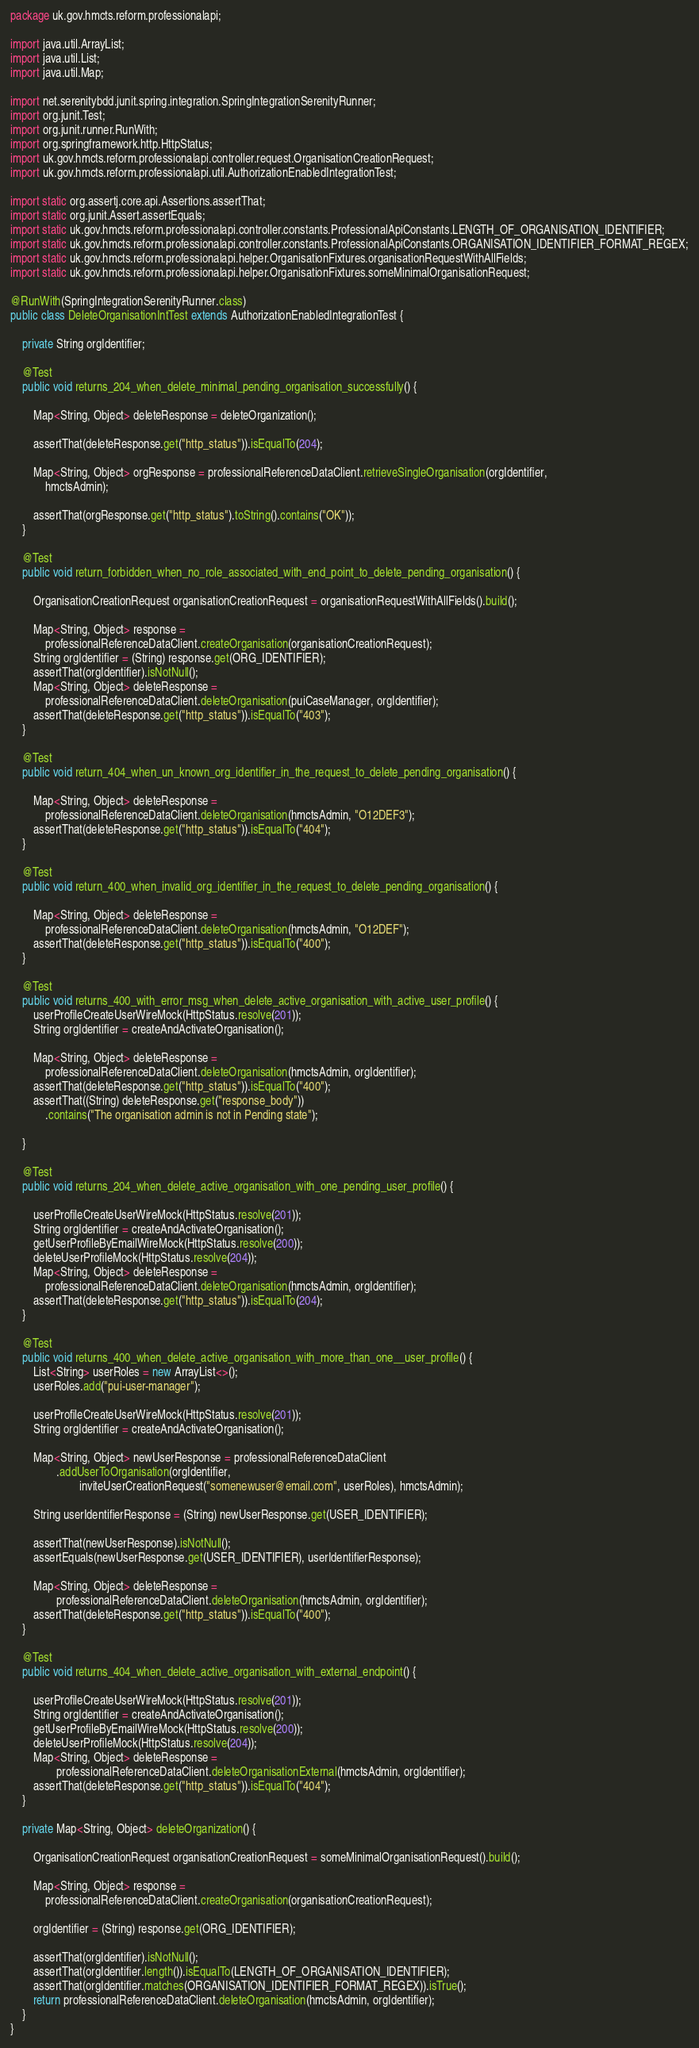Convert code to text. <code><loc_0><loc_0><loc_500><loc_500><_Java_>package uk.gov.hmcts.reform.professionalapi;

import java.util.ArrayList;
import java.util.List;
import java.util.Map;

import net.serenitybdd.junit.spring.integration.SpringIntegrationSerenityRunner;
import org.junit.Test;
import org.junit.runner.RunWith;
import org.springframework.http.HttpStatus;
import uk.gov.hmcts.reform.professionalapi.controller.request.OrganisationCreationRequest;
import uk.gov.hmcts.reform.professionalapi.util.AuthorizationEnabledIntegrationTest;

import static org.assertj.core.api.Assertions.assertThat;
import static org.junit.Assert.assertEquals;
import static uk.gov.hmcts.reform.professionalapi.controller.constants.ProfessionalApiConstants.LENGTH_OF_ORGANISATION_IDENTIFIER;
import static uk.gov.hmcts.reform.professionalapi.controller.constants.ProfessionalApiConstants.ORGANISATION_IDENTIFIER_FORMAT_REGEX;
import static uk.gov.hmcts.reform.professionalapi.helper.OrganisationFixtures.organisationRequestWithAllFields;
import static uk.gov.hmcts.reform.professionalapi.helper.OrganisationFixtures.someMinimalOrganisationRequest;

@RunWith(SpringIntegrationSerenityRunner.class)
public class DeleteOrganisationIntTest extends AuthorizationEnabledIntegrationTest {

    private String orgIdentifier;

    @Test
    public void returns_204_when_delete_minimal_pending_organisation_successfully() {

        Map<String, Object> deleteResponse = deleteOrganization();

        assertThat(deleteResponse.get("http_status")).isEqualTo(204);

        Map<String, Object> orgResponse = professionalReferenceDataClient.retrieveSingleOrganisation(orgIdentifier,
            hmctsAdmin);

        assertThat(orgResponse.get("http_status").toString().contains("OK"));
    }

    @Test
    public void return_forbidden_when_no_role_associated_with_end_point_to_delete_pending_organisation() {

        OrganisationCreationRequest organisationCreationRequest = organisationRequestWithAllFields().build();

        Map<String, Object> response =
            professionalReferenceDataClient.createOrganisation(organisationCreationRequest);
        String orgIdentifier = (String) response.get(ORG_IDENTIFIER);
        assertThat(orgIdentifier).isNotNull();
        Map<String, Object> deleteResponse =
            professionalReferenceDataClient.deleteOrganisation(puiCaseManager, orgIdentifier);
        assertThat(deleteResponse.get("http_status")).isEqualTo("403");
    }

    @Test
    public void return_404_when_un_known_org_identifier_in_the_request_to_delete_pending_organisation() {

        Map<String, Object> deleteResponse =
            professionalReferenceDataClient.deleteOrganisation(hmctsAdmin, "O12DEF3");
        assertThat(deleteResponse.get("http_status")).isEqualTo("404");
    }

    @Test
    public void return_400_when_invalid_org_identifier_in_the_request_to_delete_pending_organisation() {

        Map<String, Object> deleteResponse =
            professionalReferenceDataClient.deleteOrganisation(hmctsAdmin, "O12DEF");
        assertThat(deleteResponse.get("http_status")).isEqualTo("400");
    }

    @Test
    public void returns_400_with_error_msg_when_delete_active_organisation_with_active_user_profile() {
        userProfileCreateUserWireMock(HttpStatus.resolve(201));
        String orgIdentifier = createAndActivateOrganisation();

        Map<String, Object> deleteResponse =
            professionalReferenceDataClient.deleteOrganisation(hmctsAdmin, orgIdentifier);
        assertThat(deleteResponse.get("http_status")).isEqualTo("400");
        assertThat((String) deleteResponse.get("response_body"))
            .contains("The organisation admin is not in Pending state");

    }

    @Test
    public void returns_204_when_delete_active_organisation_with_one_pending_user_profile() {

        userProfileCreateUserWireMock(HttpStatus.resolve(201));
        String orgIdentifier = createAndActivateOrganisation();
        getUserProfileByEmailWireMock(HttpStatus.resolve(200));
        deleteUserProfileMock(HttpStatus.resolve(204));
        Map<String, Object> deleteResponse =
            professionalReferenceDataClient.deleteOrganisation(hmctsAdmin, orgIdentifier);
        assertThat(deleteResponse.get("http_status")).isEqualTo(204);
    }

    @Test
    public void returns_400_when_delete_active_organisation_with_more_than_one__user_profile() {
        List<String> userRoles = new ArrayList<>();
        userRoles.add("pui-user-manager");

        userProfileCreateUserWireMock(HttpStatus.resolve(201));
        String orgIdentifier = createAndActivateOrganisation();

        Map<String, Object> newUserResponse = professionalReferenceDataClient
                .addUserToOrganisation(orgIdentifier,
                        inviteUserCreationRequest("somenewuser@email.com", userRoles), hmctsAdmin);

        String userIdentifierResponse = (String) newUserResponse.get(USER_IDENTIFIER);

        assertThat(newUserResponse).isNotNull();
        assertEquals(newUserResponse.get(USER_IDENTIFIER), userIdentifierResponse);

        Map<String, Object> deleteResponse =
                professionalReferenceDataClient.deleteOrganisation(hmctsAdmin, orgIdentifier);
        assertThat(deleteResponse.get("http_status")).isEqualTo("400");
    }

    @Test
    public void returns_404_when_delete_active_organisation_with_external_endpoint() {

        userProfileCreateUserWireMock(HttpStatus.resolve(201));
        String orgIdentifier = createAndActivateOrganisation();
        getUserProfileByEmailWireMock(HttpStatus.resolve(200));
        deleteUserProfileMock(HttpStatus.resolve(204));
        Map<String, Object> deleteResponse =
                professionalReferenceDataClient.deleteOrganisationExternal(hmctsAdmin, orgIdentifier);
        assertThat(deleteResponse.get("http_status")).isEqualTo("404");
    }

    private Map<String, Object> deleteOrganization() {

        OrganisationCreationRequest organisationCreationRequest = someMinimalOrganisationRequest().build();

        Map<String, Object> response =
            professionalReferenceDataClient.createOrganisation(organisationCreationRequest);

        orgIdentifier = (String) response.get(ORG_IDENTIFIER);

        assertThat(orgIdentifier).isNotNull();
        assertThat(orgIdentifier.length()).isEqualTo(LENGTH_OF_ORGANISATION_IDENTIFIER);
        assertThat(orgIdentifier.matches(ORGANISATION_IDENTIFIER_FORMAT_REGEX)).isTrue();
        return professionalReferenceDataClient.deleteOrganisation(hmctsAdmin, orgIdentifier);
    }
}
</code> 